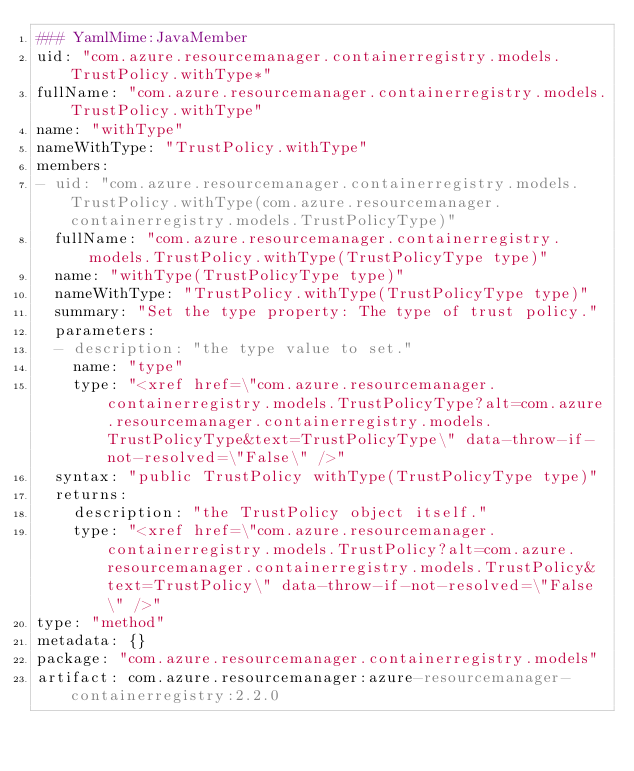Convert code to text. <code><loc_0><loc_0><loc_500><loc_500><_YAML_>### YamlMime:JavaMember
uid: "com.azure.resourcemanager.containerregistry.models.TrustPolicy.withType*"
fullName: "com.azure.resourcemanager.containerregistry.models.TrustPolicy.withType"
name: "withType"
nameWithType: "TrustPolicy.withType"
members:
- uid: "com.azure.resourcemanager.containerregistry.models.TrustPolicy.withType(com.azure.resourcemanager.containerregistry.models.TrustPolicyType)"
  fullName: "com.azure.resourcemanager.containerregistry.models.TrustPolicy.withType(TrustPolicyType type)"
  name: "withType(TrustPolicyType type)"
  nameWithType: "TrustPolicy.withType(TrustPolicyType type)"
  summary: "Set the type property: The type of trust policy."
  parameters:
  - description: "the type value to set."
    name: "type"
    type: "<xref href=\"com.azure.resourcemanager.containerregistry.models.TrustPolicyType?alt=com.azure.resourcemanager.containerregistry.models.TrustPolicyType&text=TrustPolicyType\" data-throw-if-not-resolved=\"False\" />"
  syntax: "public TrustPolicy withType(TrustPolicyType type)"
  returns:
    description: "the TrustPolicy object itself."
    type: "<xref href=\"com.azure.resourcemanager.containerregistry.models.TrustPolicy?alt=com.azure.resourcemanager.containerregistry.models.TrustPolicy&text=TrustPolicy\" data-throw-if-not-resolved=\"False\" />"
type: "method"
metadata: {}
package: "com.azure.resourcemanager.containerregistry.models"
artifact: com.azure.resourcemanager:azure-resourcemanager-containerregistry:2.2.0
</code> 